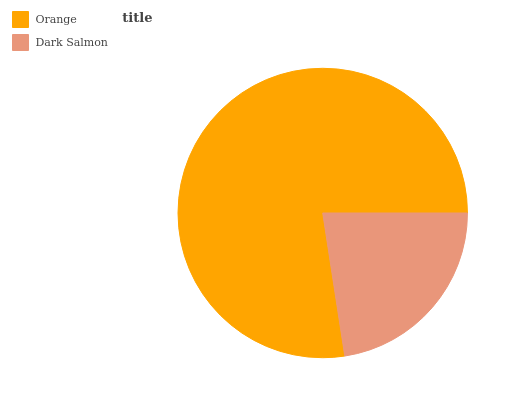Is Dark Salmon the minimum?
Answer yes or no. Yes. Is Orange the maximum?
Answer yes or no. Yes. Is Dark Salmon the maximum?
Answer yes or no. No. Is Orange greater than Dark Salmon?
Answer yes or no. Yes. Is Dark Salmon less than Orange?
Answer yes or no. Yes. Is Dark Salmon greater than Orange?
Answer yes or no. No. Is Orange less than Dark Salmon?
Answer yes or no. No. Is Orange the high median?
Answer yes or no. Yes. Is Dark Salmon the low median?
Answer yes or no. Yes. Is Dark Salmon the high median?
Answer yes or no. No. Is Orange the low median?
Answer yes or no. No. 